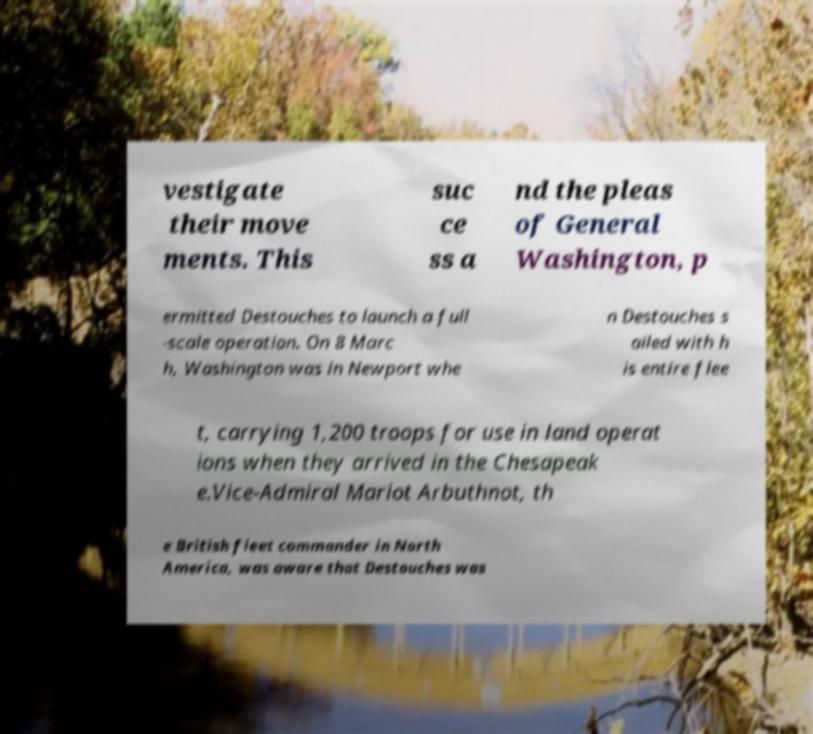Could you assist in decoding the text presented in this image and type it out clearly? vestigate their move ments. This suc ce ss a nd the pleas of General Washington, p ermitted Destouches to launch a full -scale operation. On 8 Marc h, Washington was in Newport whe n Destouches s ailed with h is entire flee t, carrying 1,200 troops for use in land operat ions when they arrived in the Chesapeak e.Vice-Admiral Mariot Arbuthnot, th e British fleet commander in North America, was aware that Destouches was 